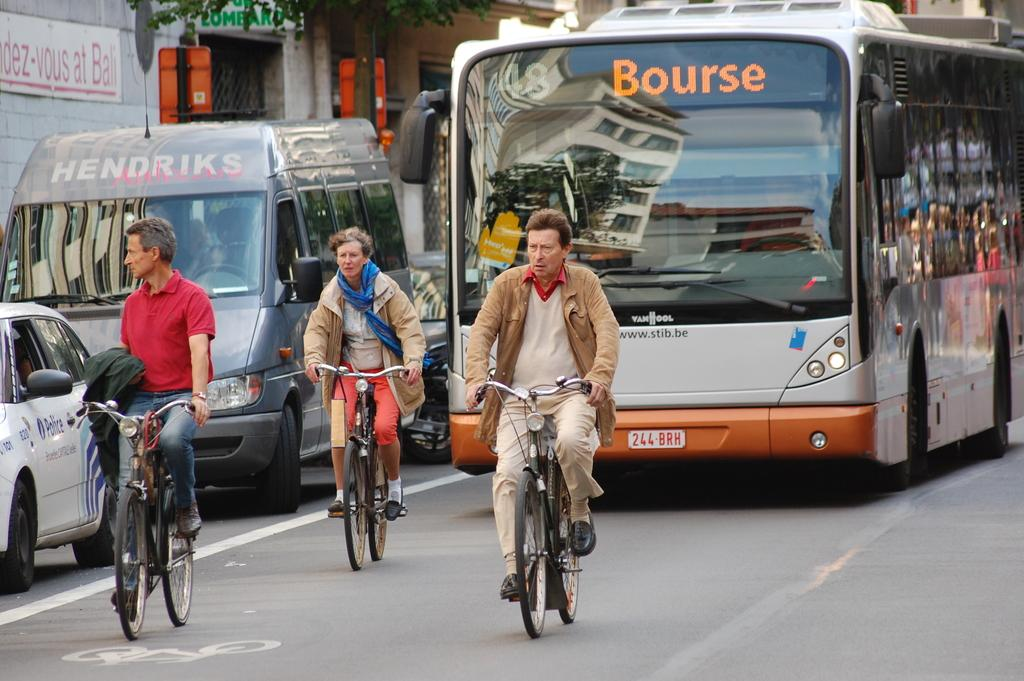How many people are riding the bicycle in the image? There are three persons riding a bicycle in the image. What else can be seen on the road in the image? There are different vehicles on the road in the image. What type of vegetation is visible in the image? There is a tree visible in the image. What structure can be seen in the image? There is a wall in the image. What type of bottle is being used to water the tree in the image? There is no bottle or watering activity present in the image. Can you tell me how many grandmothers are visible in the image? There are no grandmothers present in the image. 